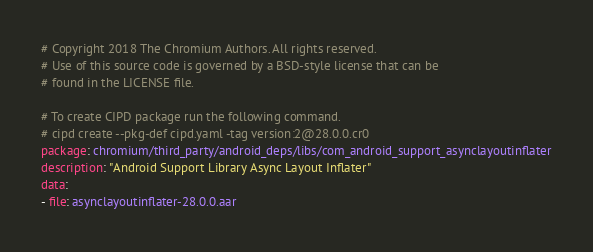Convert code to text. <code><loc_0><loc_0><loc_500><loc_500><_YAML_># Copyright 2018 The Chromium Authors. All rights reserved.
# Use of this source code is governed by a BSD-style license that can be
# found in the LICENSE file.

# To create CIPD package run the following command.
# cipd create --pkg-def cipd.yaml -tag version:2@28.0.0.cr0
package: chromium/third_party/android_deps/libs/com_android_support_asynclayoutinflater
description: "Android Support Library Async Layout Inflater"
data:
- file: asynclayoutinflater-28.0.0.aar
</code> 